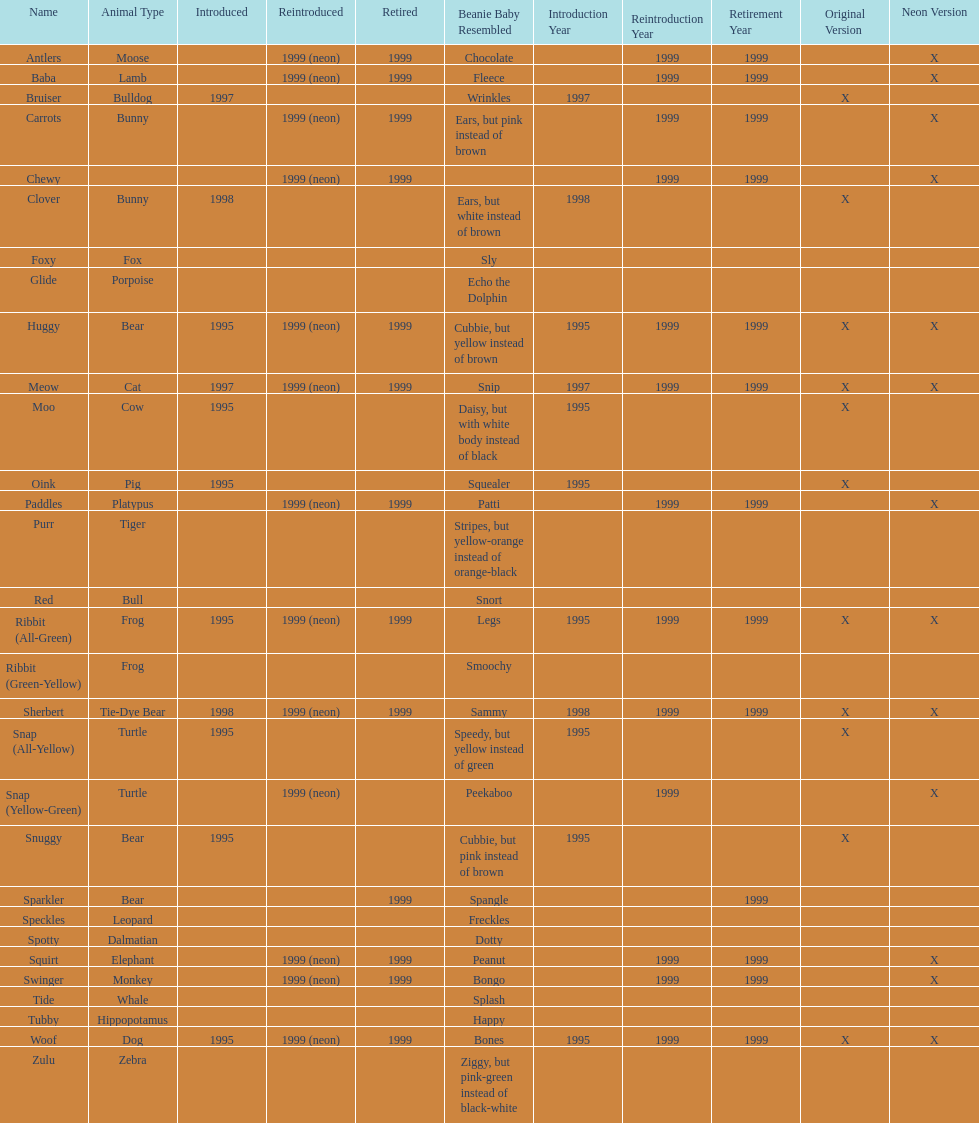Tell me the number of pillow pals reintroduced in 1999. 13. 